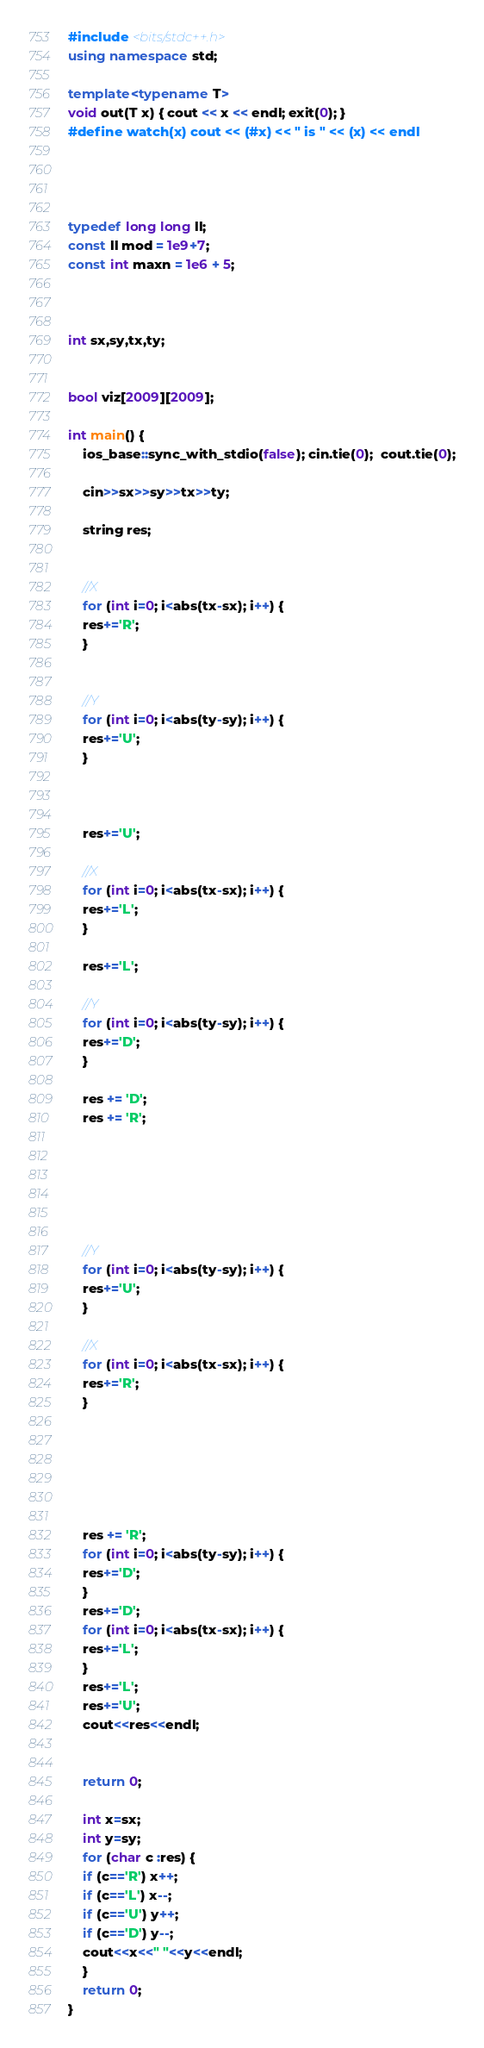Convert code to text. <code><loc_0><loc_0><loc_500><loc_500><_C++_>#include <bits/stdc++.h>
using namespace std;

template<typename T>
void out(T x) { cout << x << endl; exit(0); }
#define watch(x) cout << (#x) << " is " << (x) << endl




typedef long long ll;
const ll mod = 1e9+7;
const int maxn = 1e6 + 5;



int sx,sy,tx,ty;


bool viz[2009][2009];

int main() {
    ios_base::sync_with_stdio(false); cin.tie(0);  cout.tie(0);

    cin>>sx>>sy>>tx>>ty;

    string res;


    //X
    for (int i=0; i<abs(tx-sx); i++) {
	res+='R';
    }
    

    //Y
    for (int i=0; i<abs(ty-sy); i++) {
	res+='U';
    }



    res+='U';

    //X
    for (int i=0; i<abs(tx-sx); i++) {
	res+='L';
    }

    res+='L';

    //Y
    for (int i=0; i<abs(ty-sy); i++) {
	res+='D';
    }

    res += 'D';
    res += 'R';






    //Y
    for (int i=0; i<abs(ty-sy); i++) {
	res+='U';
    }
    
    //X
    for (int i=0; i<abs(tx-sx); i++) {
	res+='R';
    }
    




    
    res += 'R';
    for (int i=0; i<abs(ty-sy); i++) {
	res+='D';
    }
    res+='D';
    for (int i=0; i<abs(tx-sx); i++) {
	res+='L';
    }
    res+='L';
    res+='U';
    cout<<res<<endl;


    return 0;

    int x=sx;
    int y=sy;
    for (char c :res) {
	if (c=='R') x++;
	if (c=='L') x--;
	if (c=='U') y++;
	if (c=='D') y--;
	cout<<x<<" "<<y<<endl;
    }
    return 0;
}
</code> 